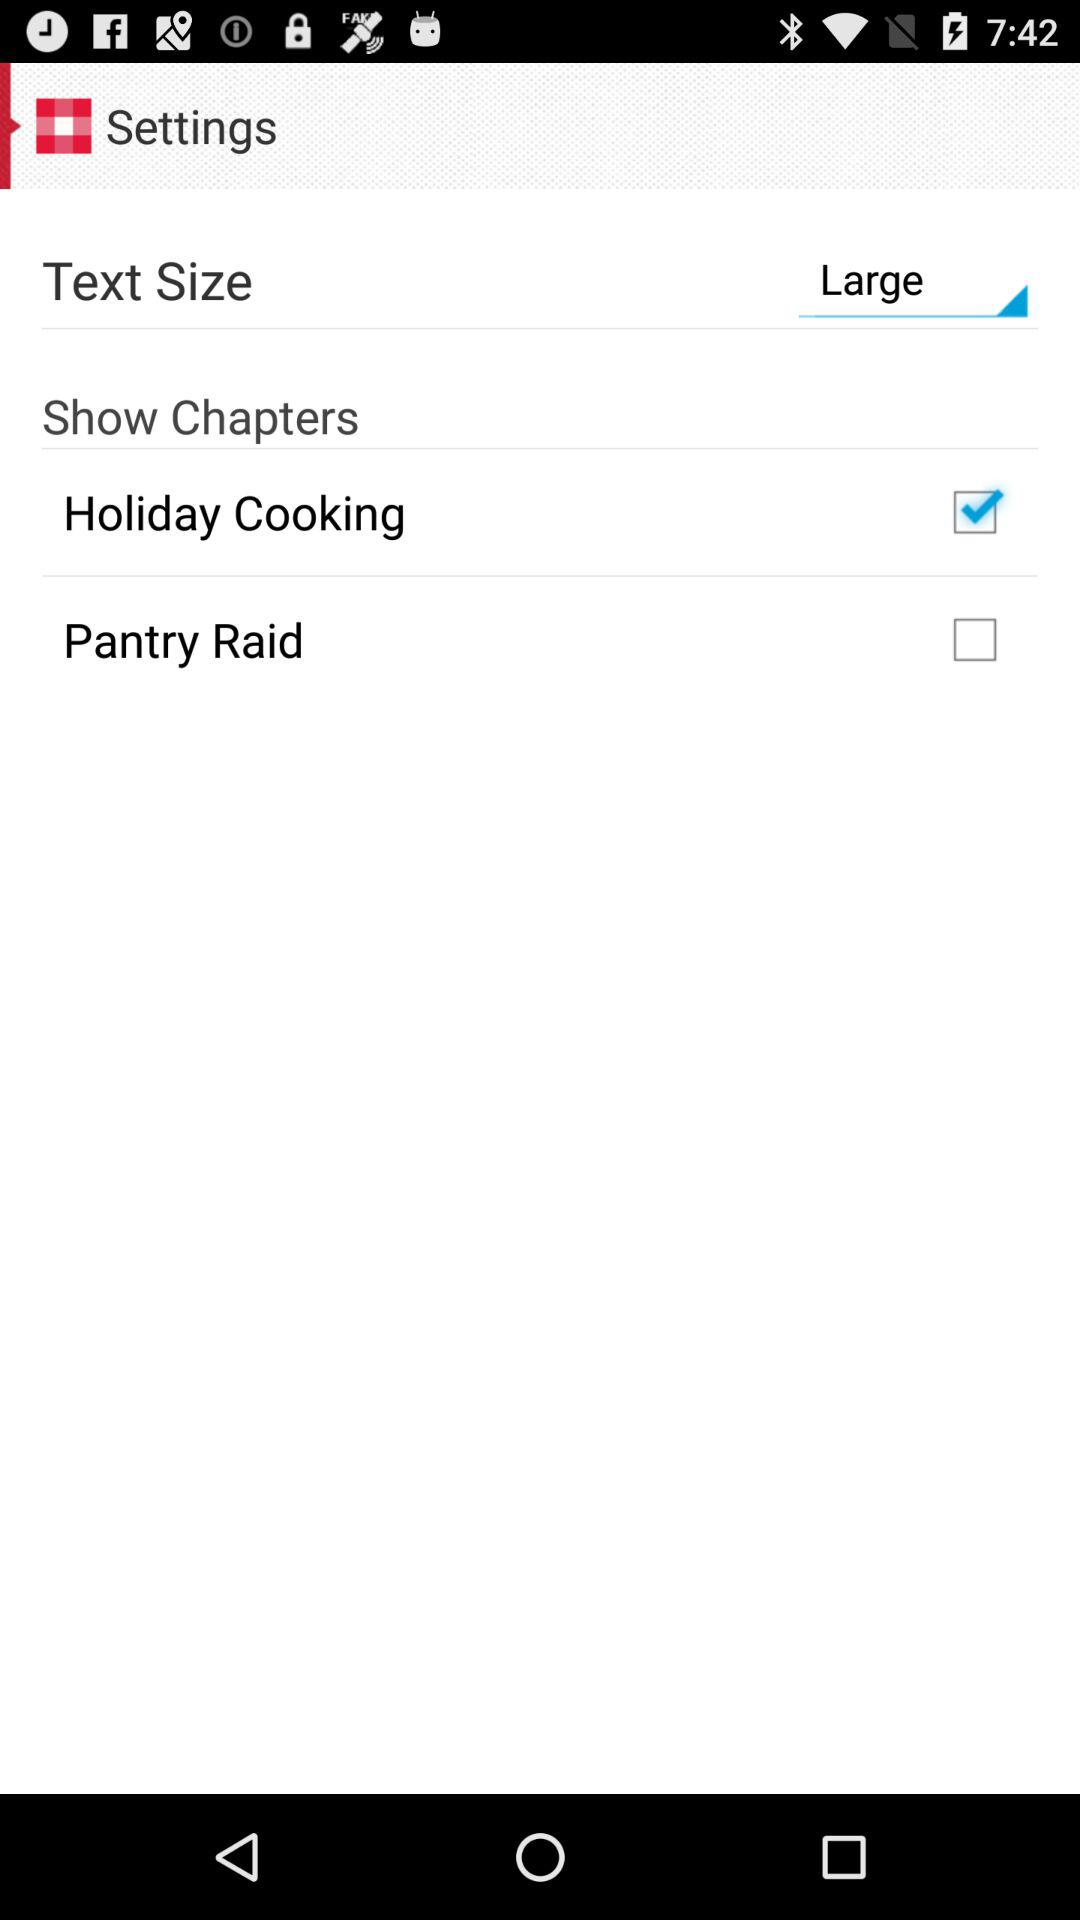What is the text size? The text size is large. 